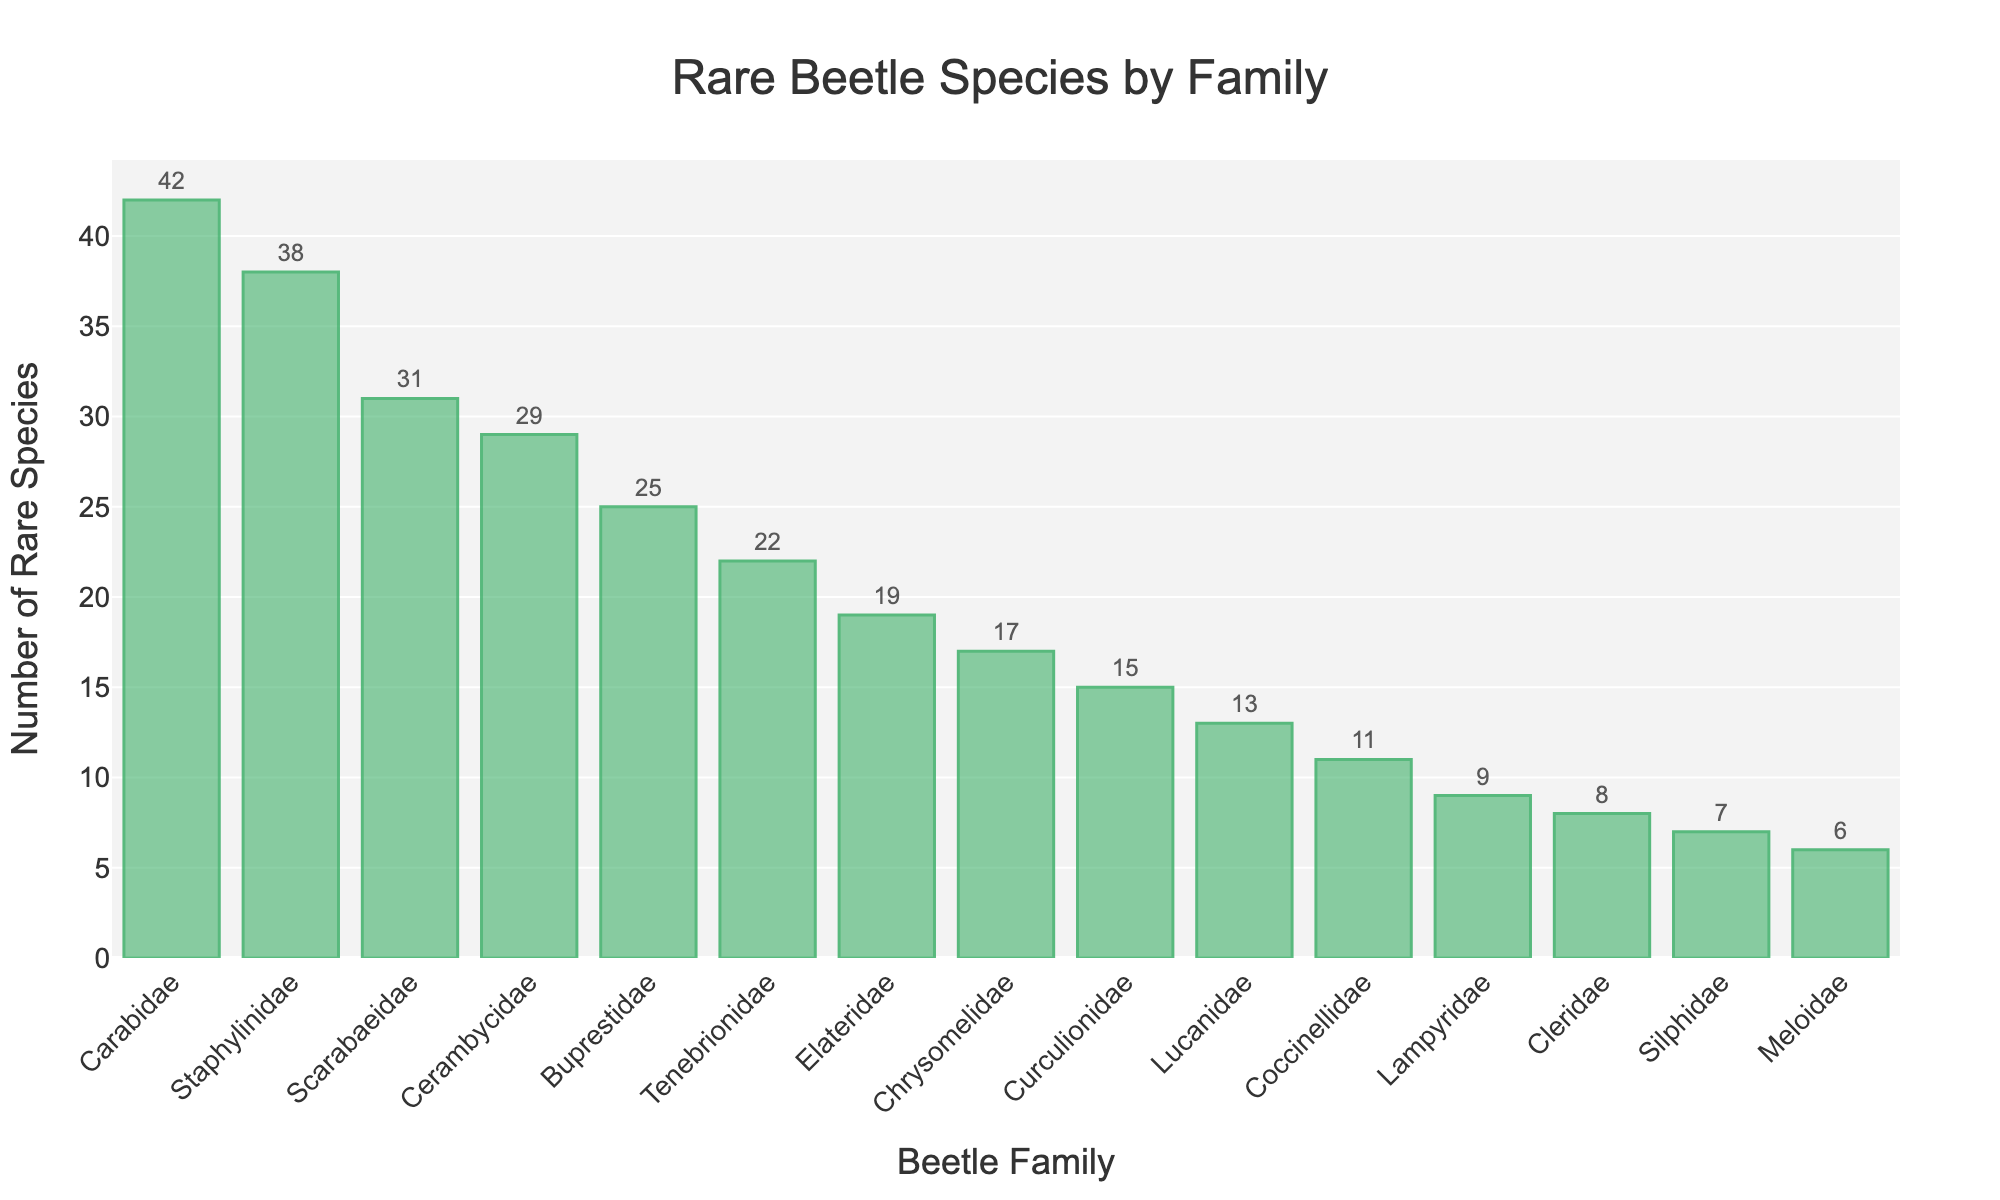Which family has the highest number of rare species? Look at the height of the bars. The bar for 'Carabidae' is the tallest, indicating the highest number of rare species.
Answer: Carabidae What is the difference in the number of rare species between Carabidae and Lucanidae? Carabidae has 42 rare species, and Lucanidae has 13. Subtract the number of Lucanidae from Carabidae: 42 - 13.
Answer: 29 Which families have fewer rare species than Tenebrionidae? Tenebrionidae has 22 rare species. Look at the bars shorter than Tenebrionidae's: Elateridae, Chrysomelidae, Curculionidae, Lucanidae, Coccinellidae, Lampyridae, Cleridae, Silphidae, and Meloidae.
Answer: Elateridae, Chrysomelidae, Curculionidae, Lucanidae, Coccinellidae, Lampyridae, Cleridae, Silphidae, Meloidae How many rare species are there in total in the families Buprestidae, Tenebrionidae, and Elateridae? Sum the number of rare species in Buprestidae (25), Tenebrionidae (22), and Elateridae (19): 25 + 22 + 19.
Answer: 66 Which family has the second-highest number of rare species? The bar for the second-highest number of rare species is for 'Staphylinidae' which has 38 rare species.
Answer: Staphylinidae What is the average number of rare species across all families? Sum the total number of rare species and divide by the number of families: (42 + 38 + 31 + 29 + 25 + 22 + 19 + 17 + 15 + 13 + 11 + 9 + 8 + 7 + 6) / 15.
Answer: 19.8 Is the number of rare species in Scarabaeidae greater than the average number of rare species? The average number of rare species is 19.8. Scarabaeidae has 31 rare species. Compare: 31 is greater than 19.8.
Answer: Yes What are the three families with the lowest number of rare species? Look at the three shortest bars. They are 'Meloidae' (6), 'Silphidae' (7), and 'Cleridae' (8).
Answer: Meloidae, Silphidae, Cleridae How many more rare species does Staphylinidae have compared to Cerambycidae? Staphylinidae has 38 rare species, and Cerambycidae has 29. Subtract Cerambycidae from Staphylinidae: 38 - 29.
Answer: 9 Which families have rare species numbers close to the median value? First, list the families in descending order of species counts: Carabidae, Staphylinidae, Scarabaeidae, Cerambycidae, Buprestidae, Tenebrionidae, Elateridae, Chrysomelidae, Curculionidae, Lucanidae, Coccinellidae, Lampyridae, Cleridae, Silphidae, Meloidae. The median is the middle value: Lucanidae with 13 rare species. The closest values are Curculionidae (15) and Coccinellidae (11).
Answer: Curculionidae, Coccinellidae 